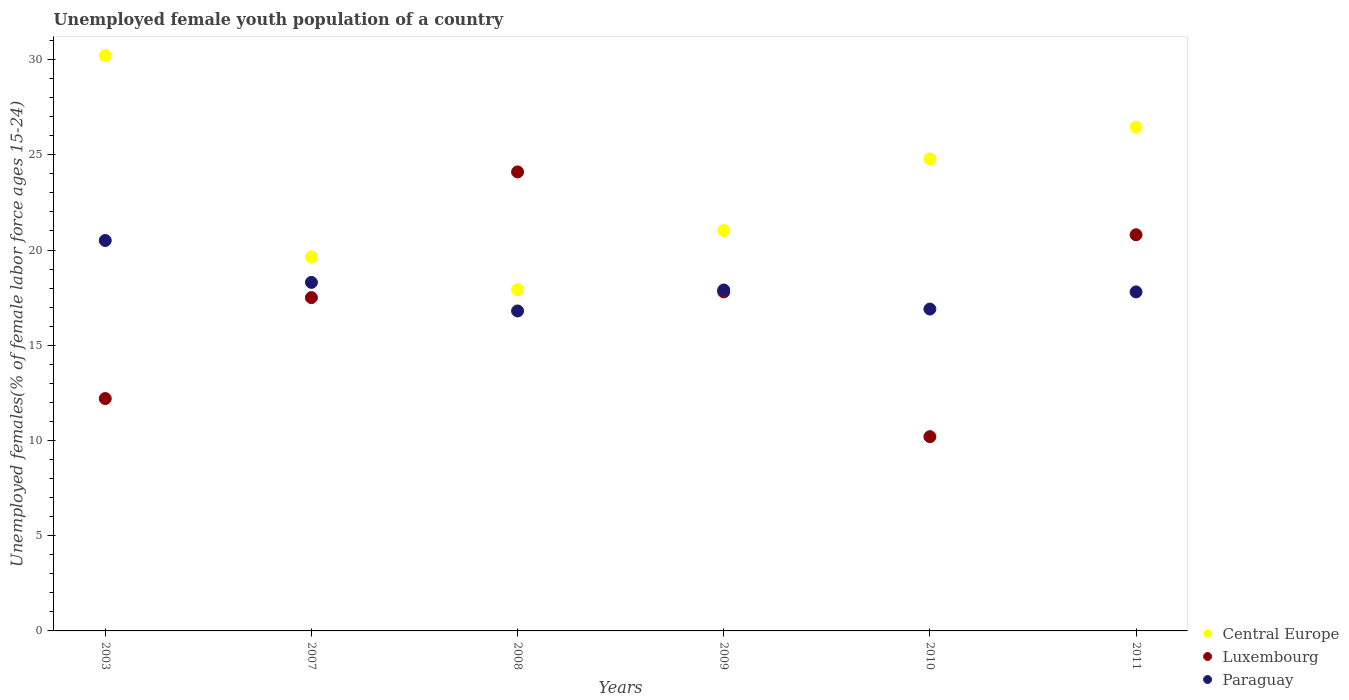How many different coloured dotlines are there?
Provide a succinct answer. 3. Is the number of dotlines equal to the number of legend labels?
Offer a very short reply. Yes. What is the percentage of unemployed female youth population in Paraguay in 2007?
Offer a very short reply. 18.3. Across all years, what is the maximum percentage of unemployed female youth population in Central Europe?
Make the answer very short. 30.21. Across all years, what is the minimum percentage of unemployed female youth population in Central Europe?
Your response must be concise. 17.91. In which year was the percentage of unemployed female youth population in Paraguay maximum?
Give a very brief answer. 2003. In which year was the percentage of unemployed female youth population in Central Europe minimum?
Provide a short and direct response. 2008. What is the total percentage of unemployed female youth population in Luxembourg in the graph?
Make the answer very short. 102.6. What is the difference between the percentage of unemployed female youth population in Paraguay in 2007 and that in 2008?
Ensure brevity in your answer.  1.5. What is the difference between the percentage of unemployed female youth population in Central Europe in 2003 and the percentage of unemployed female youth population in Paraguay in 2009?
Provide a short and direct response. 12.31. What is the average percentage of unemployed female youth population in Luxembourg per year?
Make the answer very short. 17.1. In the year 2009, what is the difference between the percentage of unemployed female youth population in Central Europe and percentage of unemployed female youth population in Luxembourg?
Provide a succinct answer. 3.22. What is the ratio of the percentage of unemployed female youth population in Central Europe in 2003 to that in 2010?
Offer a very short reply. 1.22. Is the difference between the percentage of unemployed female youth population in Central Europe in 2007 and 2011 greater than the difference between the percentage of unemployed female youth population in Luxembourg in 2007 and 2011?
Offer a terse response. No. What is the difference between the highest and the second highest percentage of unemployed female youth population in Central Europe?
Make the answer very short. 3.76. What is the difference between the highest and the lowest percentage of unemployed female youth population in Central Europe?
Provide a short and direct response. 12.29. Is the sum of the percentage of unemployed female youth population in Paraguay in 2009 and 2011 greater than the maximum percentage of unemployed female youth population in Central Europe across all years?
Your answer should be very brief. Yes. Does the percentage of unemployed female youth population in Paraguay monotonically increase over the years?
Give a very brief answer. No. Is the percentage of unemployed female youth population in Central Europe strictly greater than the percentage of unemployed female youth population in Paraguay over the years?
Provide a short and direct response. Yes. How many dotlines are there?
Your answer should be very brief. 3. How many years are there in the graph?
Give a very brief answer. 6. What is the title of the graph?
Offer a very short reply. Unemployed female youth population of a country. Does "Angola" appear as one of the legend labels in the graph?
Your answer should be very brief. No. What is the label or title of the Y-axis?
Make the answer very short. Unemployed females(% of female labor force ages 15-24). What is the Unemployed females(% of female labor force ages 15-24) of Central Europe in 2003?
Provide a short and direct response. 30.21. What is the Unemployed females(% of female labor force ages 15-24) in Luxembourg in 2003?
Your answer should be very brief. 12.2. What is the Unemployed females(% of female labor force ages 15-24) in Central Europe in 2007?
Provide a succinct answer. 19.63. What is the Unemployed females(% of female labor force ages 15-24) in Paraguay in 2007?
Keep it short and to the point. 18.3. What is the Unemployed females(% of female labor force ages 15-24) in Central Europe in 2008?
Make the answer very short. 17.91. What is the Unemployed females(% of female labor force ages 15-24) in Luxembourg in 2008?
Offer a terse response. 24.1. What is the Unemployed females(% of female labor force ages 15-24) in Paraguay in 2008?
Offer a very short reply. 16.8. What is the Unemployed females(% of female labor force ages 15-24) of Central Europe in 2009?
Make the answer very short. 21.02. What is the Unemployed females(% of female labor force ages 15-24) of Luxembourg in 2009?
Your response must be concise. 17.8. What is the Unemployed females(% of female labor force ages 15-24) in Paraguay in 2009?
Give a very brief answer. 17.9. What is the Unemployed females(% of female labor force ages 15-24) of Central Europe in 2010?
Offer a very short reply. 24.79. What is the Unemployed females(% of female labor force ages 15-24) of Luxembourg in 2010?
Your answer should be very brief. 10.2. What is the Unemployed females(% of female labor force ages 15-24) of Paraguay in 2010?
Offer a very short reply. 16.9. What is the Unemployed females(% of female labor force ages 15-24) in Central Europe in 2011?
Offer a terse response. 26.45. What is the Unemployed females(% of female labor force ages 15-24) of Luxembourg in 2011?
Your answer should be compact. 20.8. What is the Unemployed females(% of female labor force ages 15-24) in Paraguay in 2011?
Your answer should be compact. 17.8. Across all years, what is the maximum Unemployed females(% of female labor force ages 15-24) in Central Europe?
Keep it short and to the point. 30.21. Across all years, what is the maximum Unemployed females(% of female labor force ages 15-24) in Luxembourg?
Give a very brief answer. 24.1. Across all years, what is the minimum Unemployed females(% of female labor force ages 15-24) of Central Europe?
Provide a succinct answer. 17.91. Across all years, what is the minimum Unemployed females(% of female labor force ages 15-24) in Luxembourg?
Offer a terse response. 10.2. Across all years, what is the minimum Unemployed females(% of female labor force ages 15-24) of Paraguay?
Keep it short and to the point. 16.8. What is the total Unemployed females(% of female labor force ages 15-24) of Central Europe in the graph?
Make the answer very short. 140.01. What is the total Unemployed females(% of female labor force ages 15-24) in Luxembourg in the graph?
Your answer should be very brief. 102.6. What is the total Unemployed females(% of female labor force ages 15-24) in Paraguay in the graph?
Provide a succinct answer. 108.2. What is the difference between the Unemployed females(% of female labor force ages 15-24) in Central Europe in 2003 and that in 2007?
Give a very brief answer. 10.57. What is the difference between the Unemployed females(% of female labor force ages 15-24) in Luxembourg in 2003 and that in 2007?
Your answer should be compact. -5.3. What is the difference between the Unemployed females(% of female labor force ages 15-24) of Central Europe in 2003 and that in 2008?
Your answer should be compact. 12.29. What is the difference between the Unemployed females(% of female labor force ages 15-24) in Central Europe in 2003 and that in 2009?
Keep it short and to the point. 9.18. What is the difference between the Unemployed females(% of female labor force ages 15-24) in Luxembourg in 2003 and that in 2009?
Give a very brief answer. -5.6. What is the difference between the Unemployed females(% of female labor force ages 15-24) of Paraguay in 2003 and that in 2009?
Offer a very short reply. 2.6. What is the difference between the Unemployed females(% of female labor force ages 15-24) of Central Europe in 2003 and that in 2010?
Give a very brief answer. 5.42. What is the difference between the Unemployed females(% of female labor force ages 15-24) of Luxembourg in 2003 and that in 2010?
Provide a succinct answer. 2. What is the difference between the Unemployed females(% of female labor force ages 15-24) of Central Europe in 2003 and that in 2011?
Offer a very short reply. 3.76. What is the difference between the Unemployed females(% of female labor force ages 15-24) in Luxembourg in 2003 and that in 2011?
Your response must be concise. -8.6. What is the difference between the Unemployed females(% of female labor force ages 15-24) in Central Europe in 2007 and that in 2008?
Give a very brief answer. 1.72. What is the difference between the Unemployed females(% of female labor force ages 15-24) in Luxembourg in 2007 and that in 2008?
Your answer should be compact. -6.6. What is the difference between the Unemployed females(% of female labor force ages 15-24) of Paraguay in 2007 and that in 2008?
Provide a succinct answer. 1.5. What is the difference between the Unemployed females(% of female labor force ages 15-24) in Central Europe in 2007 and that in 2009?
Provide a short and direct response. -1.39. What is the difference between the Unemployed females(% of female labor force ages 15-24) in Central Europe in 2007 and that in 2010?
Your answer should be compact. -5.15. What is the difference between the Unemployed females(% of female labor force ages 15-24) of Paraguay in 2007 and that in 2010?
Make the answer very short. 1.4. What is the difference between the Unemployed females(% of female labor force ages 15-24) of Central Europe in 2007 and that in 2011?
Give a very brief answer. -6.82. What is the difference between the Unemployed females(% of female labor force ages 15-24) of Central Europe in 2008 and that in 2009?
Keep it short and to the point. -3.11. What is the difference between the Unemployed females(% of female labor force ages 15-24) of Paraguay in 2008 and that in 2009?
Your answer should be very brief. -1.1. What is the difference between the Unemployed females(% of female labor force ages 15-24) in Central Europe in 2008 and that in 2010?
Provide a succinct answer. -6.87. What is the difference between the Unemployed females(% of female labor force ages 15-24) in Central Europe in 2008 and that in 2011?
Give a very brief answer. -8.54. What is the difference between the Unemployed females(% of female labor force ages 15-24) in Central Europe in 2009 and that in 2010?
Offer a terse response. -3.76. What is the difference between the Unemployed females(% of female labor force ages 15-24) of Luxembourg in 2009 and that in 2010?
Provide a short and direct response. 7.6. What is the difference between the Unemployed females(% of female labor force ages 15-24) of Paraguay in 2009 and that in 2010?
Provide a short and direct response. 1. What is the difference between the Unemployed females(% of female labor force ages 15-24) of Central Europe in 2009 and that in 2011?
Provide a short and direct response. -5.43. What is the difference between the Unemployed females(% of female labor force ages 15-24) of Paraguay in 2009 and that in 2011?
Offer a very short reply. 0.1. What is the difference between the Unemployed females(% of female labor force ages 15-24) in Central Europe in 2010 and that in 2011?
Give a very brief answer. -1.66. What is the difference between the Unemployed females(% of female labor force ages 15-24) of Central Europe in 2003 and the Unemployed females(% of female labor force ages 15-24) of Luxembourg in 2007?
Give a very brief answer. 12.71. What is the difference between the Unemployed females(% of female labor force ages 15-24) in Central Europe in 2003 and the Unemployed females(% of female labor force ages 15-24) in Paraguay in 2007?
Offer a very short reply. 11.91. What is the difference between the Unemployed females(% of female labor force ages 15-24) in Luxembourg in 2003 and the Unemployed females(% of female labor force ages 15-24) in Paraguay in 2007?
Your answer should be very brief. -6.1. What is the difference between the Unemployed females(% of female labor force ages 15-24) of Central Europe in 2003 and the Unemployed females(% of female labor force ages 15-24) of Luxembourg in 2008?
Offer a very short reply. 6.11. What is the difference between the Unemployed females(% of female labor force ages 15-24) in Central Europe in 2003 and the Unemployed females(% of female labor force ages 15-24) in Paraguay in 2008?
Make the answer very short. 13.41. What is the difference between the Unemployed females(% of female labor force ages 15-24) in Central Europe in 2003 and the Unemployed females(% of female labor force ages 15-24) in Luxembourg in 2009?
Offer a terse response. 12.41. What is the difference between the Unemployed females(% of female labor force ages 15-24) of Central Europe in 2003 and the Unemployed females(% of female labor force ages 15-24) of Paraguay in 2009?
Give a very brief answer. 12.31. What is the difference between the Unemployed females(% of female labor force ages 15-24) in Central Europe in 2003 and the Unemployed females(% of female labor force ages 15-24) in Luxembourg in 2010?
Make the answer very short. 20.01. What is the difference between the Unemployed females(% of female labor force ages 15-24) in Central Europe in 2003 and the Unemployed females(% of female labor force ages 15-24) in Paraguay in 2010?
Offer a terse response. 13.31. What is the difference between the Unemployed females(% of female labor force ages 15-24) in Luxembourg in 2003 and the Unemployed females(% of female labor force ages 15-24) in Paraguay in 2010?
Provide a short and direct response. -4.7. What is the difference between the Unemployed females(% of female labor force ages 15-24) of Central Europe in 2003 and the Unemployed females(% of female labor force ages 15-24) of Luxembourg in 2011?
Make the answer very short. 9.41. What is the difference between the Unemployed females(% of female labor force ages 15-24) in Central Europe in 2003 and the Unemployed females(% of female labor force ages 15-24) in Paraguay in 2011?
Make the answer very short. 12.41. What is the difference between the Unemployed females(% of female labor force ages 15-24) in Luxembourg in 2003 and the Unemployed females(% of female labor force ages 15-24) in Paraguay in 2011?
Give a very brief answer. -5.6. What is the difference between the Unemployed females(% of female labor force ages 15-24) of Central Europe in 2007 and the Unemployed females(% of female labor force ages 15-24) of Luxembourg in 2008?
Provide a short and direct response. -4.47. What is the difference between the Unemployed females(% of female labor force ages 15-24) in Central Europe in 2007 and the Unemployed females(% of female labor force ages 15-24) in Paraguay in 2008?
Ensure brevity in your answer.  2.83. What is the difference between the Unemployed females(% of female labor force ages 15-24) in Central Europe in 2007 and the Unemployed females(% of female labor force ages 15-24) in Luxembourg in 2009?
Your response must be concise. 1.83. What is the difference between the Unemployed females(% of female labor force ages 15-24) in Central Europe in 2007 and the Unemployed females(% of female labor force ages 15-24) in Paraguay in 2009?
Provide a succinct answer. 1.73. What is the difference between the Unemployed females(% of female labor force ages 15-24) in Luxembourg in 2007 and the Unemployed females(% of female labor force ages 15-24) in Paraguay in 2009?
Ensure brevity in your answer.  -0.4. What is the difference between the Unemployed females(% of female labor force ages 15-24) of Central Europe in 2007 and the Unemployed females(% of female labor force ages 15-24) of Luxembourg in 2010?
Ensure brevity in your answer.  9.43. What is the difference between the Unemployed females(% of female labor force ages 15-24) in Central Europe in 2007 and the Unemployed females(% of female labor force ages 15-24) in Paraguay in 2010?
Your answer should be compact. 2.73. What is the difference between the Unemployed females(% of female labor force ages 15-24) of Central Europe in 2007 and the Unemployed females(% of female labor force ages 15-24) of Luxembourg in 2011?
Make the answer very short. -1.17. What is the difference between the Unemployed females(% of female labor force ages 15-24) in Central Europe in 2007 and the Unemployed females(% of female labor force ages 15-24) in Paraguay in 2011?
Make the answer very short. 1.83. What is the difference between the Unemployed females(% of female labor force ages 15-24) of Luxembourg in 2007 and the Unemployed females(% of female labor force ages 15-24) of Paraguay in 2011?
Offer a terse response. -0.3. What is the difference between the Unemployed females(% of female labor force ages 15-24) of Central Europe in 2008 and the Unemployed females(% of female labor force ages 15-24) of Luxembourg in 2009?
Provide a succinct answer. 0.11. What is the difference between the Unemployed females(% of female labor force ages 15-24) in Central Europe in 2008 and the Unemployed females(% of female labor force ages 15-24) in Paraguay in 2009?
Give a very brief answer. 0.01. What is the difference between the Unemployed females(% of female labor force ages 15-24) in Luxembourg in 2008 and the Unemployed females(% of female labor force ages 15-24) in Paraguay in 2009?
Offer a very short reply. 6.2. What is the difference between the Unemployed females(% of female labor force ages 15-24) in Central Europe in 2008 and the Unemployed females(% of female labor force ages 15-24) in Luxembourg in 2010?
Keep it short and to the point. 7.71. What is the difference between the Unemployed females(% of female labor force ages 15-24) in Central Europe in 2008 and the Unemployed females(% of female labor force ages 15-24) in Paraguay in 2010?
Your answer should be very brief. 1.01. What is the difference between the Unemployed females(% of female labor force ages 15-24) of Luxembourg in 2008 and the Unemployed females(% of female labor force ages 15-24) of Paraguay in 2010?
Your response must be concise. 7.2. What is the difference between the Unemployed females(% of female labor force ages 15-24) in Central Europe in 2008 and the Unemployed females(% of female labor force ages 15-24) in Luxembourg in 2011?
Give a very brief answer. -2.89. What is the difference between the Unemployed females(% of female labor force ages 15-24) of Central Europe in 2008 and the Unemployed females(% of female labor force ages 15-24) of Paraguay in 2011?
Make the answer very short. 0.11. What is the difference between the Unemployed females(% of female labor force ages 15-24) of Luxembourg in 2008 and the Unemployed females(% of female labor force ages 15-24) of Paraguay in 2011?
Your answer should be compact. 6.3. What is the difference between the Unemployed females(% of female labor force ages 15-24) in Central Europe in 2009 and the Unemployed females(% of female labor force ages 15-24) in Luxembourg in 2010?
Offer a terse response. 10.82. What is the difference between the Unemployed females(% of female labor force ages 15-24) in Central Europe in 2009 and the Unemployed females(% of female labor force ages 15-24) in Paraguay in 2010?
Keep it short and to the point. 4.12. What is the difference between the Unemployed females(% of female labor force ages 15-24) of Luxembourg in 2009 and the Unemployed females(% of female labor force ages 15-24) of Paraguay in 2010?
Your response must be concise. 0.9. What is the difference between the Unemployed females(% of female labor force ages 15-24) in Central Europe in 2009 and the Unemployed females(% of female labor force ages 15-24) in Luxembourg in 2011?
Offer a terse response. 0.22. What is the difference between the Unemployed females(% of female labor force ages 15-24) in Central Europe in 2009 and the Unemployed females(% of female labor force ages 15-24) in Paraguay in 2011?
Your answer should be compact. 3.22. What is the difference between the Unemployed females(% of female labor force ages 15-24) of Luxembourg in 2009 and the Unemployed females(% of female labor force ages 15-24) of Paraguay in 2011?
Your answer should be very brief. 0. What is the difference between the Unemployed females(% of female labor force ages 15-24) in Central Europe in 2010 and the Unemployed females(% of female labor force ages 15-24) in Luxembourg in 2011?
Your answer should be very brief. 3.99. What is the difference between the Unemployed females(% of female labor force ages 15-24) of Central Europe in 2010 and the Unemployed females(% of female labor force ages 15-24) of Paraguay in 2011?
Provide a short and direct response. 6.99. What is the average Unemployed females(% of female labor force ages 15-24) in Central Europe per year?
Give a very brief answer. 23.34. What is the average Unemployed females(% of female labor force ages 15-24) in Paraguay per year?
Keep it short and to the point. 18.03. In the year 2003, what is the difference between the Unemployed females(% of female labor force ages 15-24) in Central Europe and Unemployed females(% of female labor force ages 15-24) in Luxembourg?
Your answer should be very brief. 18.01. In the year 2003, what is the difference between the Unemployed females(% of female labor force ages 15-24) of Central Europe and Unemployed females(% of female labor force ages 15-24) of Paraguay?
Keep it short and to the point. 9.71. In the year 2007, what is the difference between the Unemployed females(% of female labor force ages 15-24) of Central Europe and Unemployed females(% of female labor force ages 15-24) of Luxembourg?
Your answer should be very brief. 2.13. In the year 2007, what is the difference between the Unemployed females(% of female labor force ages 15-24) in Central Europe and Unemployed females(% of female labor force ages 15-24) in Paraguay?
Keep it short and to the point. 1.33. In the year 2007, what is the difference between the Unemployed females(% of female labor force ages 15-24) in Luxembourg and Unemployed females(% of female labor force ages 15-24) in Paraguay?
Keep it short and to the point. -0.8. In the year 2008, what is the difference between the Unemployed females(% of female labor force ages 15-24) of Central Europe and Unemployed females(% of female labor force ages 15-24) of Luxembourg?
Provide a short and direct response. -6.19. In the year 2008, what is the difference between the Unemployed females(% of female labor force ages 15-24) of Central Europe and Unemployed females(% of female labor force ages 15-24) of Paraguay?
Provide a short and direct response. 1.11. In the year 2009, what is the difference between the Unemployed females(% of female labor force ages 15-24) in Central Europe and Unemployed females(% of female labor force ages 15-24) in Luxembourg?
Provide a short and direct response. 3.22. In the year 2009, what is the difference between the Unemployed females(% of female labor force ages 15-24) in Central Europe and Unemployed females(% of female labor force ages 15-24) in Paraguay?
Offer a terse response. 3.12. In the year 2010, what is the difference between the Unemployed females(% of female labor force ages 15-24) in Central Europe and Unemployed females(% of female labor force ages 15-24) in Luxembourg?
Keep it short and to the point. 14.59. In the year 2010, what is the difference between the Unemployed females(% of female labor force ages 15-24) in Central Europe and Unemployed females(% of female labor force ages 15-24) in Paraguay?
Your answer should be compact. 7.89. In the year 2010, what is the difference between the Unemployed females(% of female labor force ages 15-24) of Luxembourg and Unemployed females(% of female labor force ages 15-24) of Paraguay?
Offer a very short reply. -6.7. In the year 2011, what is the difference between the Unemployed females(% of female labor force ages 15-24) in Central Europe and Unemployed females(% of female labor force ages 15-24) in Luxembourg?
Make the answer very short. 5.65. In the year 2011, what is the difference between the Unemployed females(% of female labor force ages 15-24) in Central Europe and Unemployed females(% of female labor force ages 15-24) in Paraguay?
Your answer should be very brief. 8.65. What is the ratio of the Unemployed females(% of female labor force ages 15-24) of Central Europe in 2003 to that in 2007?
Your answer should be compact. 1.54. What is the ratio of the Unemployed females(% of female labor force ages 15-24) of Luxembourg in 2003 to that in 2007?
Make the answer very short. 0.7. What is the ratio of the Unemployed females(% of female labor force ages 15-24) of Paraguay in 2003 to that in 2007?
Give a very brief answer. 1.12. What is the ratio of the Unemployed females(% of female labor force ages 15-24) of Central Europe in 2003 to that in 2008?
Provide a succinct answer. 1.69. What is the ratio of the Unemployed females(% of female labor force ages 15-24) in Luxembourg in 2003 to that in 2008?
Make the answer very short. 0.51. What is the ratio of the Unemployed females(% of female labor force ages 15-24) of Paraguay in 2003 to that in 2008?
Keep it short and to the point. 1.22. What is the ratio of the Unemployed females(% of female labor force ages 15-24) of Central Europe in 2003 to that in 2009?
Ensure brevity in your answer.  1.44. What is the ratio of the Unemployed females(% of female labor force ages 15-24) in Luxembourg in 2003 to that in 2009?
Provide a short and direct response. 0.69. What is the ratio of the Unemployed females(% of female labor force ages 15-24) in Paraguay in 2003 to that in 2009?
Provide a succinct answer. 1.15. What is the ratio of the Unemployed females(% of female labor force ages 15-24) in Central Europe in 2003 to that in 2010?
Keep it short and to the point. 1.22. What is the ratio of the Unemployed females(% of female labor force ages 15-24) in Luxembourg in 2003 to that in 2010?
Your response must be concise. 1.2. What is the ratio of the Unemployed females(% of female labor force ages 15-24) in Paraguay in 2003 to that in 2010?
Your answer should be very brief. 1.21. What is the ratio of the Unemployed females(% of female labor force ages 15-24) of Central Europe in 2003 to that in 2011?
Provide a succinct answer. 1.14. What is the ratio of the Unemployed females(% of female labor force ages 15-24) in Luxembourg in 2003 to that in 2011?
Offer a terse response. 0.59. What is the ratio of the Unemployed females(% of female labor force ages 15-24) of Paraguay in 2003 to that in 2011?
Offer a very short reply. 1.15. What is the ratio of the Unemployed females(% of female labor force ages 15-24) in Central Europe in 2007 to that in 2008?
Provide a short and direct response. 1.1. What is the ratio of the Unemployed females(% of female labor force ages 15-24) of Luxembourg in 2007 to that in 2008?
Keep it short and to the point. 0.73. What is the ratio of the Unemployed females(% of female labor force ages 15-24) in Paraguay in 2007 to that in 2008?
Make the answer very short. 1.09. What is the ratio of the Unemployed females(% of female labor force ages 15-24) of Central Europe in 2007 to that in 2009?
Your response must be concise. 0.93. What is the ratio of the Unemployed females(% of female labor force ages 15-24) in Luxembourg in 2007 to that in 2009?
Ensure brevity in your answer.  0.98. What is the ratio of the Unemployed females(% of female labor force ages 15-24) in Paraguay in 2007 to that in 2009?
Offer a terse response. 1.02. What is the ratio of the Unemployed females(% of female labor force ages 15-24) of Central Europe in 2007 to that in 2010?
Your response must be concise. 0.79. What is the ratio of the Unemployed females(% of female labor force ages 15-24) of Luxembourg in 2007 to that in 2010?
Offer a very short reply. 1.72. What is the ratio of the Unemployed females(% of female labor force ages 15-24) of Paraguay in 2007 to that in 2010?
Keep it short and to the point. 1.08. What is the ratio of the Unemployed females(% of female labor force ages 15-24) in Central Europe in 2007 to that in 2011?
Your response must be concise. 0.74. What is the ratio of the Unemployed females(% of female labor force ages 15-24) in Luxembourg in 2007 to that in 2011?
Your answer should be very brief. 0.84. What is the ratio of the Unemployed females(% of female labor force ages 15-24) in Paraguay in 2007 to that in 2011?
Offer a terse response. 1.03. What is the ratio of the Unemployed females(% of female labor force ages 15-24) of Central Europe in 2008 to that in 2009?
Keep it short and to the point. 0.85. What is the ratio of the Unemployed females(% of female labor force ages 15-24) in Luxembourg in 2008 to that in 2009?
Your response must be concise. 1.35. What is the ratio of the Unemployed females(% of female labor force ages 15-24) in Paraguay in 2008 to that in 2009?
Your answer should be very brief. 0.94. What is the ratio of the Unemployed females(% of female labor force ages 15-24) of Central Europe in 2008 to that in 2010?
Offer a terse response. 0.72. What is the ratio of the Unemployed females(% of female labor force ages 15-24) of Luxembourg in 2008 to that in 2010?
Provide a succinct answer. 2.36. What is the ratio of the Unemployed females(% of female labor force ages 15-24) of Central Europe in 2008 to that in 2011?
Your response must be concise. 0.68. What is the ratio of the Unemployed females(% of female labor force ages 15-24) in Luxembourg in 2008 to that in 2011?
Offer a terse response. 1.16. What is the ratio of the Unemployed females(% of female labor force ages 15-24) of Paraguay in 2008 to that in 2011?
Make the answer very short. 0.94. What is the ratio of the Unemployed females(% of female labor force ages 15-24) of Central Europe in 2009 to that in 2010?
Provide a short and direct response. 0.85. What is the ratio of the Unemployed females(% of female labor force ages 15-24) in Luxembourg in 2009 to that in 2010?
Make the answer very short. 1.75. What is the ratio of the Unemployed females(% of female labor force ages 15-24) of Paraguay in 2009 to that in 2010?
Your answer should be compact. 1.06. What is the ratio of the Unemployed females(% of female labor force ages 15-24) of Central Europe in 2009 to that in 2011?
Ensure brevity in your answer.  0.79. What is the ratio of the Unemployed females(% of female labor force ages 15-24) in Luxembourg in 2009 to that in 2011?
Ensure brevity in your answer.  0.86. What is the ratio of the Unemployed females(% of female labor force ages 15-24) of Paraguay in 2009 to that in 2011?
Your answer should be very brief. 1.01. What is the ratio of the Unemployed females(% of female labor force ages 15-24) of Central Europe in 2010 to that in 2011?
Your answer should be compact. 0.94. What is the ratio of the Unemployed females(% of female labor force ages 15-24) of Luxembourg in 2010 to that in 2011?
Your answer should be very brief. 0.49. What is the ratio of the Unemployed females(% of female labor force ages 15-24) of Paraguay in 2010 to that in 2011?
Keep it short and to the point. 0.95. What is the difference between the highest and the second highest Unemployed females(% of female labor force ages 15-24) of Central Europe?
Ensure brevity in your answer.  3.76. What is the difference between the highest and the second highest Unemployed females(% of female labor force ages 15-24) of Luxembourg?
Give a very brief answer. 3.3. What is the difference between the highest and the lowest Unemployed females(% of female labor force ages 15-24) of Central Europe?
Keep it short and to the point. 12.29. What is the difference between the highest and the lowest Unemployed females(% of female labor force ages 15-24) of Luxembourg?
Give a very brief answer. 13.9. 